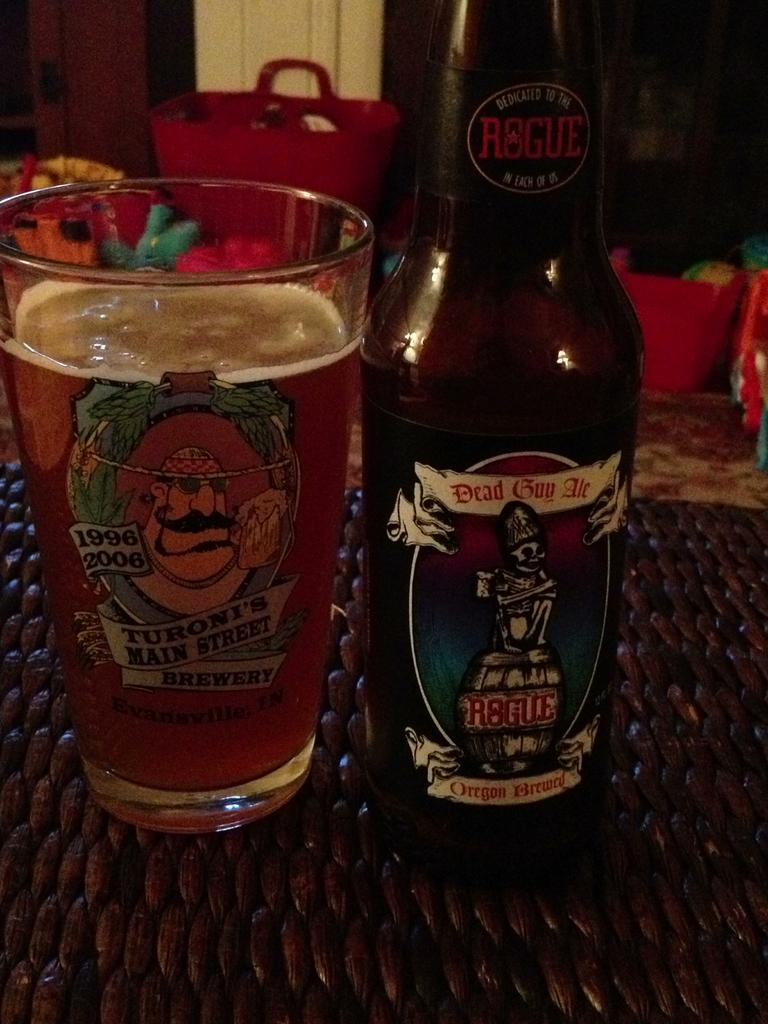<image>
Create a compact narrative representing the image presented. A bottle of Dead Guy Ale next to a full drinking glass. 